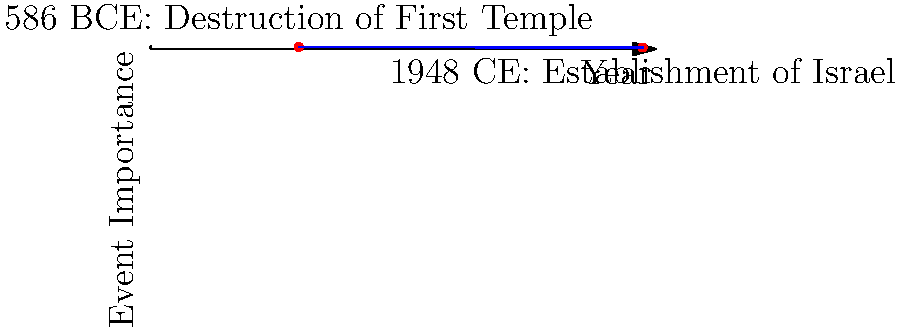On a timeline graph, two significant events in Jewish history are marked: the destruction of the First Temple in 586 BCE and the establishment of the State of Israel in 1948 CE. Calculate the slope of the line connecting these two points, considering the x-axis represents years (with BCE as negative values) and the y-axis represents the event's importance on a scale of 0 to 10. To calculate the slope of the line connecting these two points, we'll use the slope formula:

$$ m = \frac{y_2 - y_1}{x_2 - x_1} $$

Where $(x_1, y_1)$ is the first point and $(x_2, y_2)$ is the second point.

Step 1: Identify the coordinates of the two points.
- Destruction of First Temple: $(-586, 8)$
- Establishment of Israel: $(1948, 6)$

Step 2: Apply the slope formula.
$$ m = \frac{6 - 8}{1948 - (-586)} = \frac{-2}{2534} $$

Step 3: Simplify the fraction.
$$ m = -\frac{1}{1267} $$

This negative slope indicates that the line is descending from left to right, which could be interpreted as a decrease in the perceived importance or impact of events over time in this specific comparison.
Answer: $-\frac{1}{1267}$ 